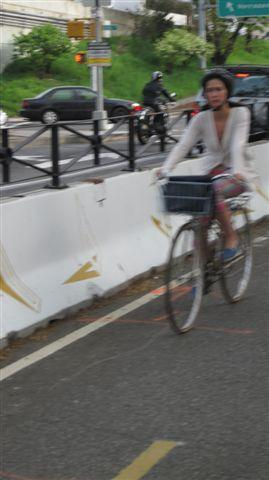Question: how many people are on bikes?
Choices:
A. 1.
B. 3.
C. 2.
D. 6.
Answer with the letter. Answer: C Question: what color is the street sign in the back?
Choices:
A. Red.
B. Amber.
C. Green.
D. White.
Answer with the letter. Answer: C Question: what color are her shoes?
Choices:
A. Black.
B. Brown.
C. Blue.
D. Red.
Answer with the letter. Answer: C Question: where is the helmet?
Choices:
A. On the floor.
B. On her head.
C. On the bike.
D. On the table.
Answer with the letter. Answer: B Question: what is she riding?
Choices:
A. A bike.
B. Motorcycle.
C. Bus.
D. Train.
Answer with the letter. Answer: A 